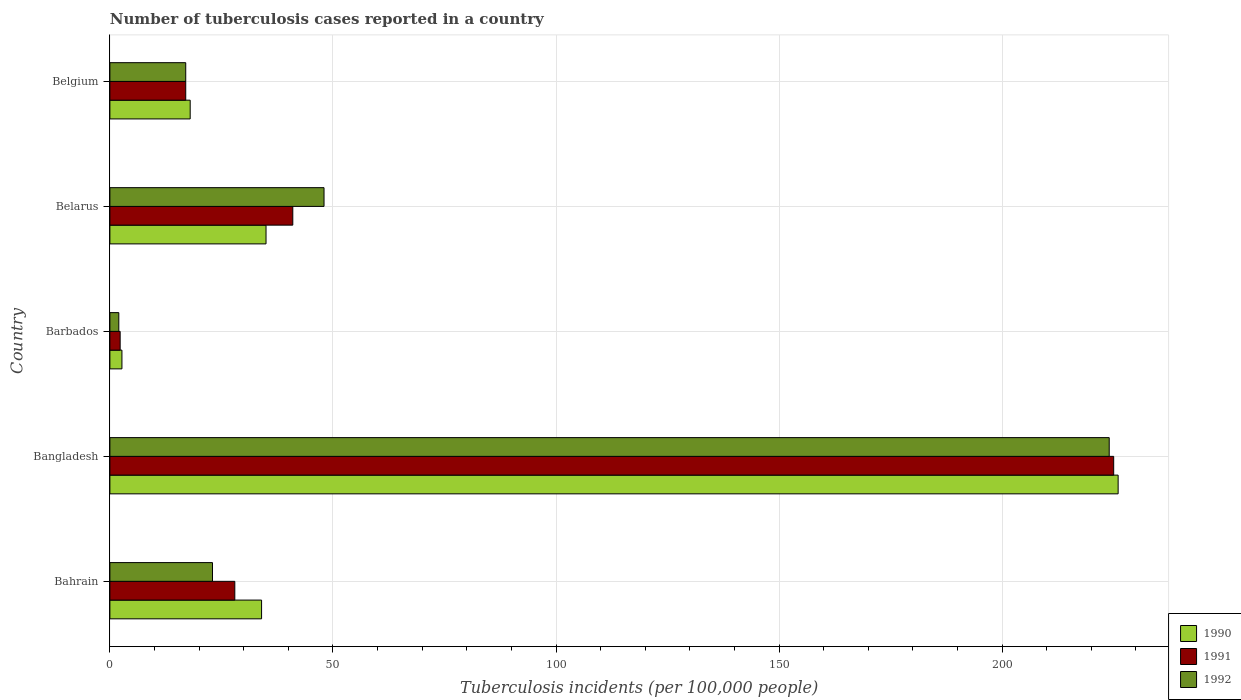How many different coloured bars are there?
Give a very brief answer. 3. How many groups of bars are there?
Keep it short and to the point. 5. Are the number of bars per tick equal to the number of legend labels?
Your answer should be very brief. Yes. How many bars are there on the 1st tick from the top?
Give a very brief answer. 3. What is the label of the 5th group of bars from the top?
Your response must be concise. Bahrain. What is the number of tuberculosis cases reported in in 1990 in Belgium?
Your response must be concise. 18. Across all countries, what is the maximum number of tuberculosis cases reported in in 1992?
Your answer should be very brief. 224. In which country was the number of tuberculosis cases reported in in 1990 minimum?
Your response must be concise. Barbados. What is the total number of tuberculosis cases reported in in 1990 in the graph?
Your answer should be compact. 315.7. What is the difference between the number of tuberculosis cases reported in in 1992 in Belarus and that in Belgium?
Keep it short and to the point. 31. What is the difference between the number of tuberculosis cases reported in in 1991 in Barbados and the number of tuberculosis cases reported in in 1990 in Belarus?
Your answer should be compact. -32.7. What is the average number of tuberculosis cases reported in in 1990 per country?
Offer a terse response. 63.14. In how many countries, is the number of tuberculosis cases reported in in 1990 greater than 120 ?
Keep it short and to the point. 1. What is the ratio of the number of tuberculosis cases reported in in 1990 in Belarus to that in Belgium?
Keep it short and to the point. 1.94. What is the difference between the highest and the second highest number of tuberculosis cases reported in in 1992?
Ensure brevity in your answer.  176. What is the difference between the highest and the lowest number of tuberculosis cases reported in in 1991?
Make the answer very short. 222.7. Is the sum of the number of tuberculosis cases reported in in 1992 in Barbados and Belgium greater than the maximum number of tuberculosis cases reported in in 1991 across all countries?
Offer a terse response. No. What does the 2nd bar from the top in Bahrain represents?
Ensure brevity in your answer.  1991. What does the 1st bar from the bottom in Bangladesh represents?
Ensure brevity in your answer.  1990. How many bars are there?
Your response must be concise. 15. Does the graph contain any zero values?
Provide a short and direct response. No. Does the graph contain grids?
Your answer should be compact. Yes. Where does the legend appear in the graph?
Keep it short and to the point. Bottom right. What is the title of the graph?
Provide a succinct answer. Number of tuberculosis cases reported in a country. Does "1985" appear as one of the legend labels in the graph?
Offer a terse response. No. What is the label or title of the X-axis?
Your answer should be compact. Tuberculosis incidents (per 100,0 people). What is the Tuberculosis incidents (per 100,000 people) in 1990 in Bahrain?
Give a very brief answer. 34. What is the Tuberculosis incidents (per 100,000 people) in 1990 in Bangladesh?
Your answer should be compact. 226. What is the Tuberculosis incidents (per 100,000 people) of 1991 in Bangladesh?
Your response must be concise. 225. What is the Tuberculosis incidents (per 100,000 people) in 1992 in Bangladesh?
Make the answer very short. 224. What is the Tuberculosis incidents (per 100,000 people) in 1990 in Barbados?
Ensure brevity in your answer.  2.7. What is the Tuberculosis incidents (per 100,000 people) in 1991 in Barbados?
Your answer should be very brief. 2.3. What is the Tuberculosis incidents (per 100,000 people) of 1990 in Belarus?
Offer a terse response. 35. What is the Tuberculosis incidents (per 100,000 people) of 1991 in Belarus?
Your answer should be very brief. 41. What is the Tuberculosis incidents (per 100,000 people) in 1992 in Belarus?
Your response must be concise. 48. What is the Tuberculosis incidents (per 100,000 people) of 1991 in Belgium?
Your response must be concise. 17. What is the Tuberculosis incidents (per 100,000 people) of 1992 in Belgium?
Ensure brevity in your answer.  17. Across all countries, what is the maximum Tuberculosis incidents (per 100,000 people) of 1990?
Provide a short and direct response. 226. Across all countries, what is the maximum Tuberculosis incidents (per 100,000 people) in 1991?
Keep it short and to the point. 225. Across all countries, what is the maximum Tuberculosis incidents (per 100,000 people) in 1992?
Make the answer very short. 224. Across all countries, what is the minimum Tuberculosis incidents (per 100,000 people) of 1990?
Your answer should be very brief. 2.7. Across all countries, what is the minimum Tuberculosis incidents (per 100,000 people) of 1992?
Your answer should be compact. 2. What is the total Tuberculosis incidents (per 100,000 people) of 1990 in the graph?
Offer a terse response. 315.7. What is the total Tuberculosis incidents (per 100,000 people) of 1991 in the graph?
Your answer should be compact. 313.3. What is the total Tuberculosis incidents (per 100,000 people) of 1992 in the graph?
Give a very brief answer. 314. What is the difference between the Tuberculosis incidents (per 100,000 people) in 1990 in Bahrain and that in Bangladesh?
Your answer should be very brief. -192. What is the difference between the Tuberculosis incidents (per 100,000 people) in 1991 in Bahrain and that in Bangladesh?
Give a very brief answer. -197. What is the difference between the Tuberculosis incidents (per 100,000 people) of 1992 in Bahrain and that in Bangladesh?
Offer a terse response. -201. What is the difference between the Tuberculosis incidents (per 100,000 people) of 1990 in Bahrain and that in Barbados?
Give a very brief answer. 31.3. What is the difference between the Tuberculosis incidents (per 100,000 people) of 1991 in Bahrain and that in Barbados?
Make the answer very short. 25.7. What is the difference between the Tuberculosis incidents (per 100,000 people) of 1992 in Bahrain and that in Belarus?
Give a very brief answer. -25. What is the difference between the Tuberculosis incidents (per 100,000 people) of 1990 in Bahrain and that in Belgium?
Your answer should be compact. 16. What is the difference between the Tuberculosis incidents (per 100,000 people) in 1990 in Bangladesh and that in Barbados?
Provide a succinct answer. 223.3. What is the difference between the Tuberculosis incidents (per 100,000 people) in 1991 in Bangladesh and that in Barbados?
Your answer should be compact. 222.7. What is the difference between the Tuberculosis incidents (per 100,000 people) of 1992 in Bangladesh and that in Barbados?
Make the answer very short. 222. What is the difference between the Tuberculosis incidents (per 100,000 people) of 1990 in Bangladesh and that in Belarus?
Offer a very short reply. 191. What is the difference between the Tuberculosis incidents (per 100,000 people) in 1991 in Bangladesh and that in Belarus?
Provide a succinct answer. 184. What is the difference between the Tuberculosis incidents (per 100,000 people) in 1992 in Bangladesh and that in Belarus?
Provide a succinct answer. 176. What is the difference between the Tuberculosis incidents (per 100,000 people) in 1990 in Bangladesh and that in Belgium?
Keep it short and to the point. 208. What is the difference between the Tuberculosis incidents (per 100,000 people) in 1991 in Bangladesh and that in Belgium?
Provide a succinct answer. 208. What is the difference between the Tuberculosis incidents (per 100,000 people) of 1992 in Bangladesh and that in Belgium?
Provide a succinct answer. 207. What is the difference between the Tuberculosis incidents (per 100,000 people) in 1990 in Barbados and that in Belarus?
Give a very brief answer. -32.3. What is the difference between the Tuberculosis incidents (per 100,000 people) in 1991 in Barbados and that in Belarus?
Provide a succinct answer. -38.7. What is the difference between the Tuberculosis incidents (per 100,000 people) of 1992 in Barbados and that in Belarus?
Your answer should be very brief. -46. What is the difference between the Tuberculosis incidents (per 100,000 people) of 1990 in Barbados and that in Belgium?
Ensure brevity in your answer.  -15.3. What is the difference between the Tuberculosis incidents (per 100,000 people) in 1991 in Barbados and that in Belgium?
Ensure brevity in your answer.  -14.7. What is the difference between the Tuberculosis incidents (per 100,000 people) in 1992 in Barbados and that in Belgium?
Ensure brevity in your answer.  -15. What is the difference between the Tuberculosis incidents (per 100,000 people) in 1990 in Belarus and that in Belgium?
Ensure brevity in your answer.  17. What is the difference between the Tuberculosis incidents (per 100,000 people) of 1991 in Belarus and that in Belgium?
Ensure brevity in your answer.  24. What is the difference between the Tuberculosis incidents (per 100,000 people) in 1990 in Bahrain and the Tuberculosis incidents (per 100,000 people) in 1991 in Bangladesh?
Ensure brevity in your answer.  -191. What is the difference between the Tuberculosis incidents (per 100,000 people) of 1990 in Bahrain and the Tuberculosis incidents (per 100,000 people) of 1992 in Bangladesh?
Ensure brevity in your answer.  -190. What is the difference between the Tuberculosis incidents (per 100,000 people) in 1991 in Bahrain and the Tuberculosis incidents (per 100,000 people) in 1992 in Bangladesh?
Your answer should be compact. -196. What is the difference between the Tuberculosis incidents (per 100,000 people) of 1990 in Bahrain and the Tuberculosis incidents (per 100,000 people) of 1991 in Barbados?
Offer a terse response. 31.7. What is the difference between the Tuberculosis incidents (per 100,000 people) of 1991 in Bahrain and the Tuberculosis incidents (per 100,000 people) of 1992 in Barbados?
Keep it short and to the point. 26. What is the difference between the Tuberculosis incidents (per 100,000 people) of 1990 in Bahrain and the Tuberculosis incidents (per 100,000 people) of 1991 in Belarus?
Offer a terse response. -7. What is the difference between the Tuberculosis incidents (per 100,000 people) of 1990 in Bahrain and the Tuberculosis incidents (per 100,000 people) of 1992 in Belarus?
Keep it short and to the point. -14. What is the difference between the Tuberculosis incidents (per 100,000 people) in 1991 in Bahrain and the Tuberculosis incidents (per 100,000 people) in 1992 in Belarus?
Provide a short and direct response. -20. What is the difference between the Tuberculosis incidents (per 100,000 people) in 1990 in Bahrain and the Tuberculosis incidents (per 100,000 people) in 1991 in Belgium?
Your answer should be very brief. 17. What is the difference between the Tuberculosis incidents (per 100,000 people) of 1991 in Bahrain and the Tuberculosis incidents (per 100,000 people) of 1992 in Belgium?
Give a very brief answer. 11. What is the difference between the Tuberculosis incidents (per 100,000 people) in 1990 in Bangladesh and the Tuberculosis incidents (per 100,000 people) in 1991 in Barbados?
Offer a terse response. 223.7. What is the difference between the Tuberculosis incidents (per 100,000 people) in 1990 in Bangladesh and the Tuberculosis incidents (per 100,000 people) in 1992 in Barbados?
Keep it short and to the point. 224. What is the difference between the Tuberculosis incidents (per 100,000 people) of 1991 in Bangladesh and the Tuberculosis incidents (per 100,000 people) of 1992 in Barbados?
Offer a very short reply. 223. What is the difference between the Tuberculosis incidents (per 100,000 people) of 1990 in Bangladesh and the Tuberculosis incidents (per 100,000 people) of 1991 in Belarus?
Keep it short and to the point. 185. What is the difference between the Tuberculosis incidents (per 100,000 people) in 1990 in Bangladesh and the Tuberculosis incidents (per 100,000 people) in 1992 in Belarus?
Provide a short and direct response. 178. What is the difference between the Tuberculosis incidents (per 100,000 people) in 1991 in Bangladesh and the Tuberculosis incidents (per 100,000 people) in 1992 in Belarus?
Provide a succinct answer. 177. What is the difference between the Tuberculosis incidents (per 100,000 people) in 1990 in Bangladesh and the Tuberculosis incidents (per 100,000 people) in 1991 in Belgium?
Your response must be concise. 209. What is the difference between the Tuberculosis incidents (per 100,000 people) in 1990 in Bangladesh and the Tuberculosis incidents (per 100,000 people) in 1992 in Belgium?
Your answer should be compact. 209. What is the difference between the Tuberculosis incidents (per 100,000 people) of 1991 in Bangladesh and the Tuberculosis incidents (per 100,000 people) of 1992 in Belgium?
Offer a very short reply. 208. What is the difference between the Tuberculosis incidents (per 100,000 people) of 1990 in Barbados and the Tuberculosis incidents (per 100,000 people) of 1991 in Belarus?
Provide a short and direct response. -38.3. What is the difference between the Tuberculosis incidents (per 100,000 people) in 1990 in Barbados and the Tuberculosis incidents (per 100,000 people) in 1992 in Belarus?
Your response must be concise. -45.3. What is the difference between the Tuberculosis incidents (per 100,000 people) in 1991 in Barbados and the Tuberculosis incidents (per 100,000 people) in 1992 in Belarus?
Make the answer very short. -45.7. What is the difference between the Tuberculosis incidents (per 100,000 people) of 1990 in Barbados and the Tuberculosis incidents (per 100,000 people) of 1991 in Belgium?
Provide a succinct answer. -14.3. What is the difference between the Tuberculosis incidents (per 100,000 people) in 1990 in Barbados and the Tuberculosis incidents (per 100,000 people) in 1992 in Belgium?
Offer a very short reply. -14.3. What is the difference between the Tuberculosis incidents (per 100,000 people) of 1991 in Barbados and the Tuberculosis incidents (per 100,000 people) of 1992 in Belgium?
Provide a succinct answer. -14.7. What is the difference between the Tuberculosis incidents (per 100,000 people) in 1990 in Belarus and the Tuberculosis incidents (per 100,000 people) in 1991 in Belgium?
Your response must be concise. 18. What is the difference between the Tuberculosis incidents (per 100,000 people) of 1990 in Belarus and the Tuberculosis incidents (per 100,000 people) of 1992 in Belgium?
Your answer should be compact. 18. What is the average Tuberculosis incidents (per 100,000 people) in 1990 per country?
Offer a very short reply. 63.14. What is the average Tuberculosis incidents (per 100,000 people) of 1991 per country?
Provide a succinct answer. 62.66. What is the average Tuberculosis incidents (per 100,000 people) in 1992 per country?
Make the answer very short. 62.8. What is the difference between the Tuberculosis incidents (per 100,000 people) in 1991 and Tuberculosis incidents (per 100,000 people) in 1992 in Bahrain?
Ensure brevity in your answer.  5. What is the difference between the Tuberculosis incidents (per 100,000 people) in 1990 and Tuberculosis incidents (per 100,000 people) in 1992 in Barbados?
Ensure brevity in your answer.  0.7. What is the difference between the Tuberculosis incidents (per 100,000 people) in 1990 and Tuberculosis incidents (per 100,000 people) in 1991 in Belarus?
Provide a succinct answer. -6. What is the ratio of the Tuberculosis incidents (per 100,000 people) of 1990 in Bahrain to that in Bangladesh?
Provide a succinct answer. 0.15. What is the ratio of the Tuberculosis incidents (per 100,000 people) of 1991 in Bahrain to that in Bangladesh?
Offer a terse response. 0.12. What is the ratio of the Tuberculosis incidents (per 100,000 people) in 1992 in Bahrain to that in Bangladesh?
Ensure brevity in your answer.  0.1. What is the ratio of the Tuberculosis incidents (per 100,000 people) of 1990 in Bahrain to that in Barbados?
Ensure brevity in your answer.  12.59. What is the ratio of the Tuberculosis incidents (per 100,000 people) in 1991 in Bahrain to that in Barbados?
Your answer should be compact. 12.17. What is the ratio of the Tuberculosis incidents (per 100,000 people) of 1990 in Bahrain to that in Belarus?
Your answer should be very brief. 0.97. What is the ratio of the Tuberculosis incidents (per 100,000 people) in 1991 in Bahrain to that in Belarus?
Keep it short and to the point. 0.68. What is the ratio of the Tuberculosis incidents (per 100,000 people) of 1992 in Bahrain to that in Belarus?
Make the answer very short. 0.48. What is the ratio of the Tuberculosis incidents (per 100,000 people) of 1990 in Bahrain to that in Belgium?
Offer a very short reply. 1.89. What is the ratio of the Tuberculosis incidents (per 100,000 people) in 1991 in Bahrain to that in Belgium?
Provide a succinct answer. 1.65. What is the ratio of the Tuberculosis incidents (per 100,000 people) of 1992 in Bahrain to that in Belgium?
Your answer should be compact. 1.35. What is the ratio of the Tuberculosis incidents (per 100,000 people) of 1990 in Bangladesh to that in Barbados?
Your answer should be very brief. 83.7. What is the ratio of the Tuberculosis incidents (per 100,000 people) of 1991 in Bangladesh to that in Barbados?
Provide a succinct answer. 97.83. What is the ratio of the Tuberculosis incidents (per 100,000 people) of 1992 in Bangladesh to that in Barbados?
Provide a short and direct response. 112. What is the ratio of the Tuberculosis incidents (per 100,000 people) in 1990 in Bangladesh to that in Belarus?
Your answer should be very brief. 6.46. What is the ratio of the Tuberculosis incidents (per 100,000 people) in 1991 in Bangladesh to that in Belarus?
Your answer should be compact. 5.49. What is the ratio of the Tuberculosis incidents (per 100,000 people) in 1992 in Bangladesh to that in Belarus?
Provide a succinct answer. 4.67. What is the ratio of the Tuberculosis incidents (per 100,000 people) in 1990 in Bangladesh to that in Belgium?
Provide a succinct answer. 12.56. What is the ratio of the Tuberculosis incidents (per 100,000 people) of 1991 in Bangladesh to that in Belgium?
Your response must be concise. 13.24. What is the ratio of the Tuberculosis incidents (per 100,000 people) in 1992 in Bangladesh to that in Belgium?
Make the answer very short. 13.18. What is the ratio of the Tuberculosis incidents (per 100,000 people) in 1990 in Barbados to that in Belarus?
Offer a very short reply. 0.08. What is the ratio of the Tuberculosis incidents (per 100,000 people) in 1991 in Barbados to that in Belarus?
Provide a short and direct response. 0.06. What is the ratio of the Tuberculosis incidents (per 100,000 people) of 1992 in Barbados to that in Belarus?
Your response must be concise. 0.04. What is the ratio of the Tuberculosis incidents (per 100,000 people) in 1990 in Barbados to that in Belgium?
Offer a very short reply. 0.15. What is the ratio of the Tuberculosis incidents (per 100,000 people) in 1991 in Barbados to that in Belgium?
Your response must be concise. 0.14. What is the ratio of the Tuberculosis incidents (per 100,000 people) in 1992 in Barbados to that in Belgium?
Give a very brief answer. 0.12. What is the ratio of the Tuberculosis incidents (per 100,000 people) in 1990 in Belarus to that in Belgium?
Offer a very short reply. 1.94. What is the ratio of the Tuberculosis incidents (per 100,000 people) in 1991 in Belarus to that in Belgium?
Offer a very short reply. 2.41. What is the ratio of the Tuberculosis incidents (per 100,000 people) of 1992 in Belarus to that in Belgium?
Give a very brief answer. 2.82. What is the difference between the highest and the second highest Tuberculosis incidents (per 100,000 people) in 1990?
Provide a succinct answer. 191. What is the difference between the highest and the second highest Tuberculosis incidents (per 100,000 people) of 1991?
Provide a succinct answer. 184. What is the difference between the highest and the second highest Tuberculosis incidents (per 100,000 people) of 1992?
Offer a terse response. 176. What is the difference between the highest and the lowest Tuberculosis incidents (per 100,000 people) in 1990?
Keep it short and to the point. 223.3. What is the difference between the highest and the lowest Tuberculosis incidents (per 100,000 people) in 1991?
Offer a terse response. 222.7. What is the difference between the highest and the lowest Tuberculosis incidents (per 100,000 people) in 1992?
Keep it short and to the point. 222. 